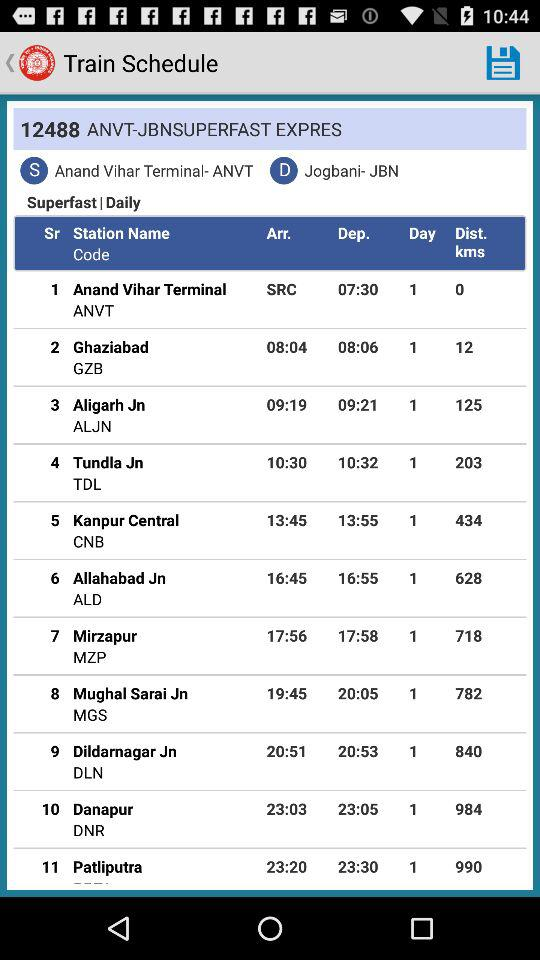Is the train slow or superfast? The train is superfast. 